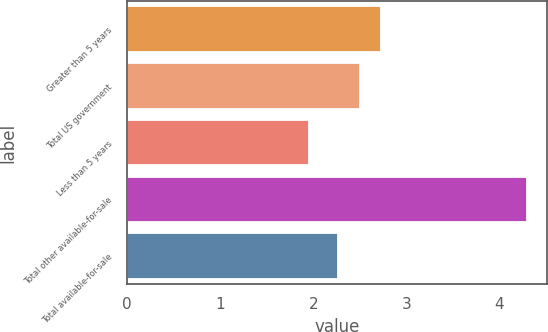Convert chart to OTSL. <chart><loc_0><loc_0><loc_500><loc_500><bar_chart><fcel>Greater than 5 years<fcel>Total US government<fcel>Less than 5 years<fcel>Total other available-for-sale<fcel>Total available-for-sale<nl><fcel>2.73<fcel>2.5<fcel>1.95<fcel>4.3<fcel>2.27<nl></chart> 